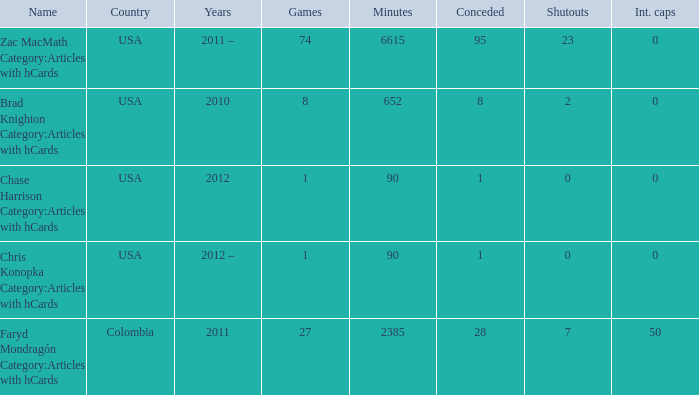When chase harrison category:articles with hcards is the name what is the year? 2012.0. 